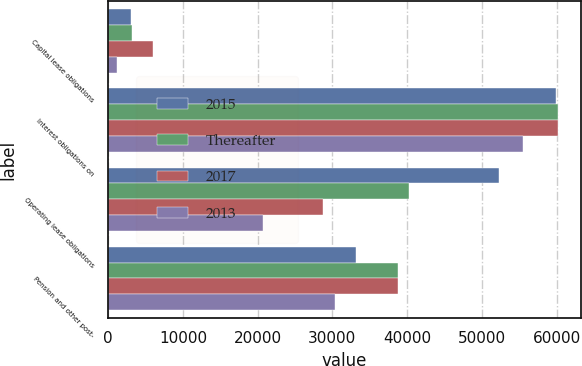Convert chart. <chart><loc_0><loc_0><loc_500><loc_500><stacked_bar_chart><ecel><fcel>Capital lease obligations<fcel>Interest obligations on<fcel>Operating lease obligations<fcel>Pension and other post-<nl><fcel>2015<fcel>3096<fcel>59850<fcel>52306<fcel>33200<nl><fcel>Thereafter<fcel>3171<fcel>60238<fcel>40190<fcel>38800<nl><fcel>2017<fcel>6036<fcel>60238<fcel>28785<fcel>38800<nl><fcel>2013<fcel>1236<fcel>55513<fcel>20715<fcel>30300<nl></chart> 